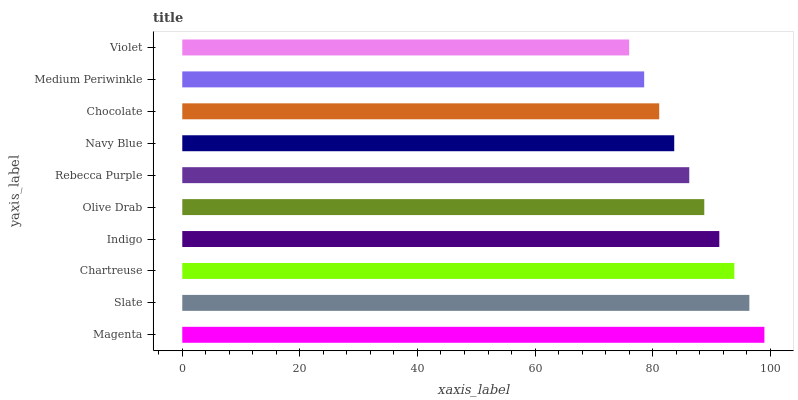Is Violet the minimum?
Answer yes or no. Yes. Is Magenta the maximum?
Answer yes or no. Yes. Is Slate the minimum?
Answer yes or no. No. Is Slate the maximum?
Answer yes or no. No. Is Magenta greater than Slate?
Answer yes or no. Yes. Is Slate less than Magenta?
Answer yes or no. Yes. Is Slate greater than Magenta?
Answer yes or no. No. Is Magenta less than Slate?
Answer yes or no. No. Is Olive Drab the high median?
Answer yes or no. Yes. Is Rebecca Purple the low median?
Answer yes or no. Yes. Is Medium Periwinkle the high median?
Answer yes or no. No. Is Medium Periwinkle the low median?
Answer yes or no. No. 